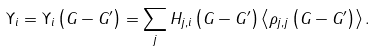Convert formula to latex. <formula><loc_0><loc_0><loc_500><loc_500>\Upsilon _ { i } = \Upsilon _ { i } \left ( G - G ^ { \prime } \right ) = \sum _ { j } H _ { j , i } \left ( G - G ^ { \prime } \right ) \left \langle \rho _ { j , j } \left ( G - G ^ { \prime } \right ) \right \rangle .</formula> 